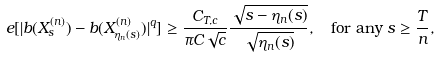<formula> <loc_0><loc_0><loc_500><loc_500>\ e [ | b ( X _ { s } ^ { ( n ) } ) - b ( X _ { \eta _ { n } ( s ) } ^ { ( n ) } ) | ^ { q } ] & \geq \frac { C _ { T , c } } { \pi C \sqrt { c } } \frac { \sqrt { s - \eta _ { n } ( s ) } } { \sqrt { \eta _ { n } ( s ) } } , \quad \text {for any } s \geq \frac { T } { n } ,</formula> 